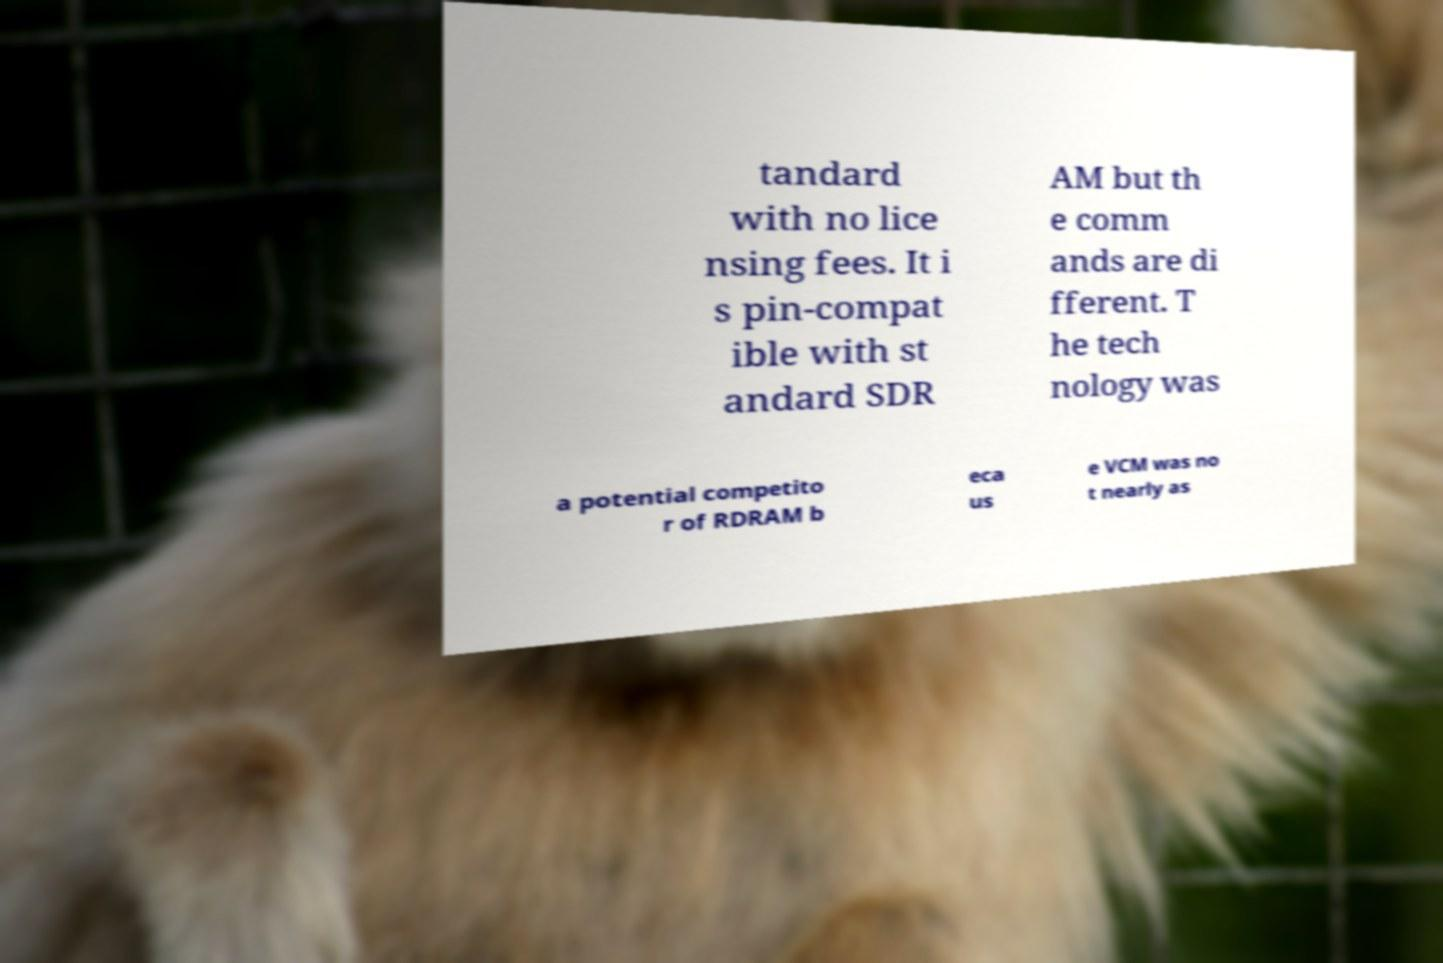Could you assist in decoding the text presented in this image and type it out clearly? tandard with no lice nsing fees. It i s pin-compat ible with st andard SDR AM but th e comm ands are di fferent. T he tech nology was a potential competito r of RDRAM b eca us e VCM was no t nearly as 